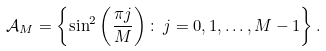Convert formula to latex. <formula><loc_0><loc_0><loc_500><loc_500>\mathcal { A } _ { M } = \left \{ \sin ^ { 2 } \left ( \frac { \pi j } M \right ) \colon \, j = 0 , 1 , \dots , M - 1 \right \} .</formula> 